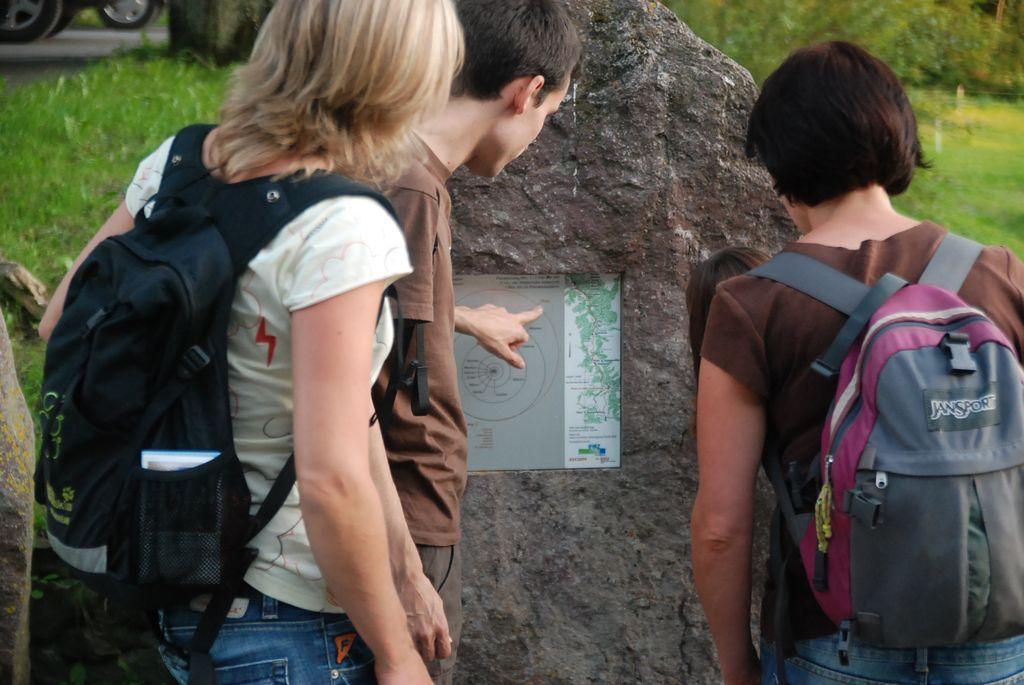What brand is the backpack on the right?
Your response must be concise. Jansport. 